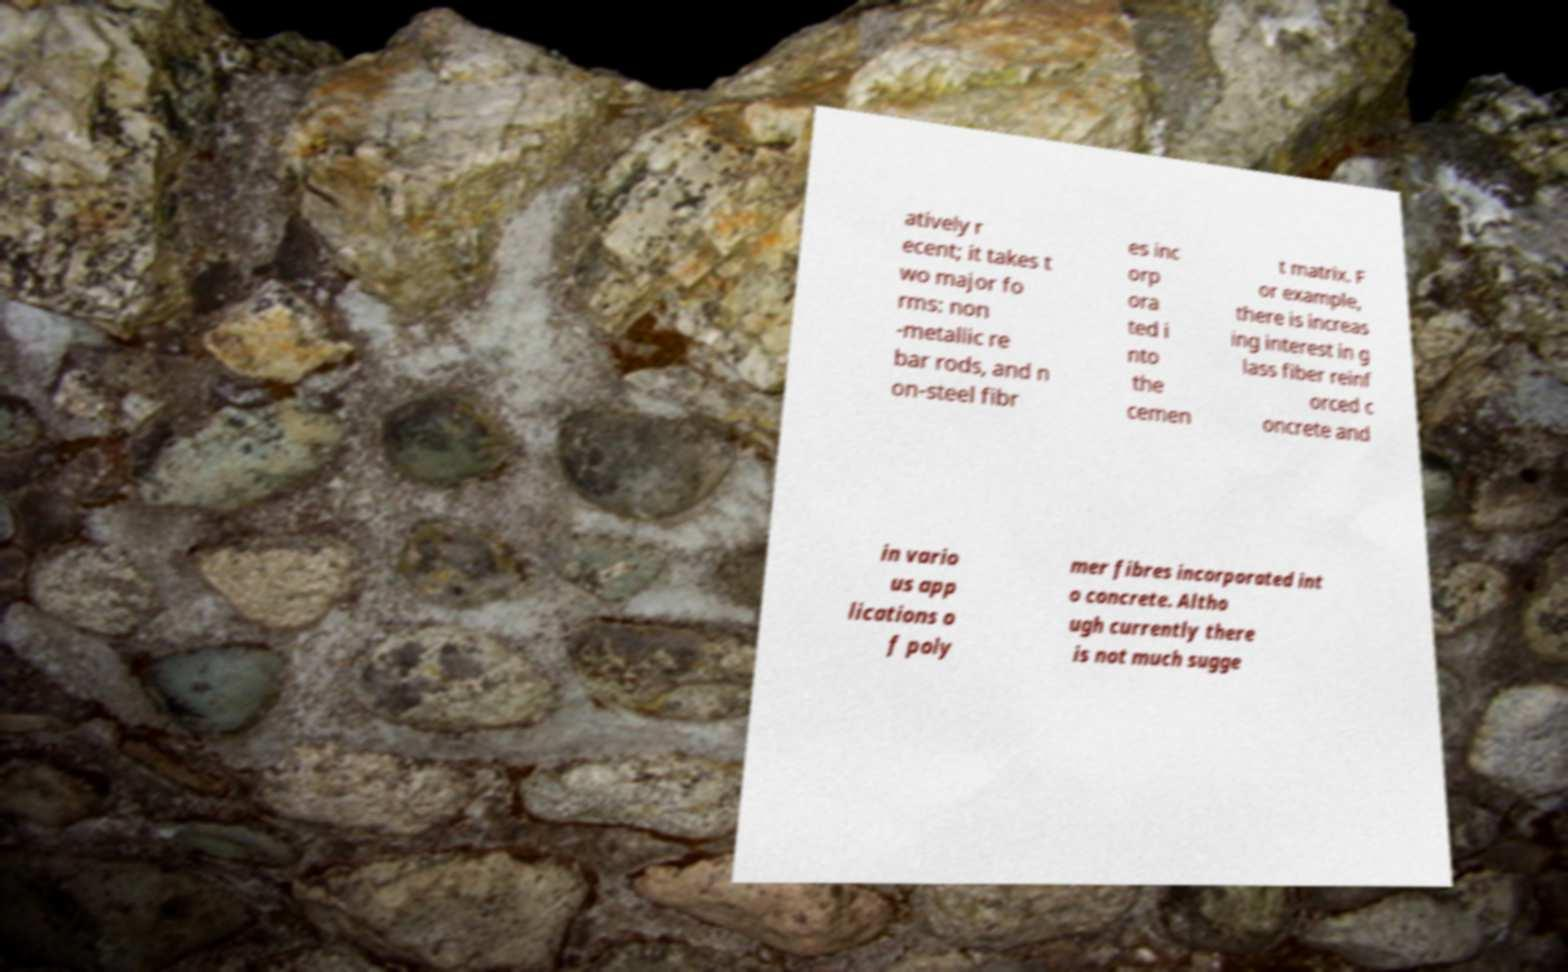Please read and relay the text visible in this image. What does it say? atively r ecent; it takes t wo major fo rms: non -metallic re bar rods, and n on-steel fibr es inc orp ora ted i nto the cemen t matrix. F or example, there is increas ing interest in g lass fiber reinf orced c oncrete and in vario us app lications o f poly mer fibres incorporated int o concrete. Altho ugh currently there is not much sugge 